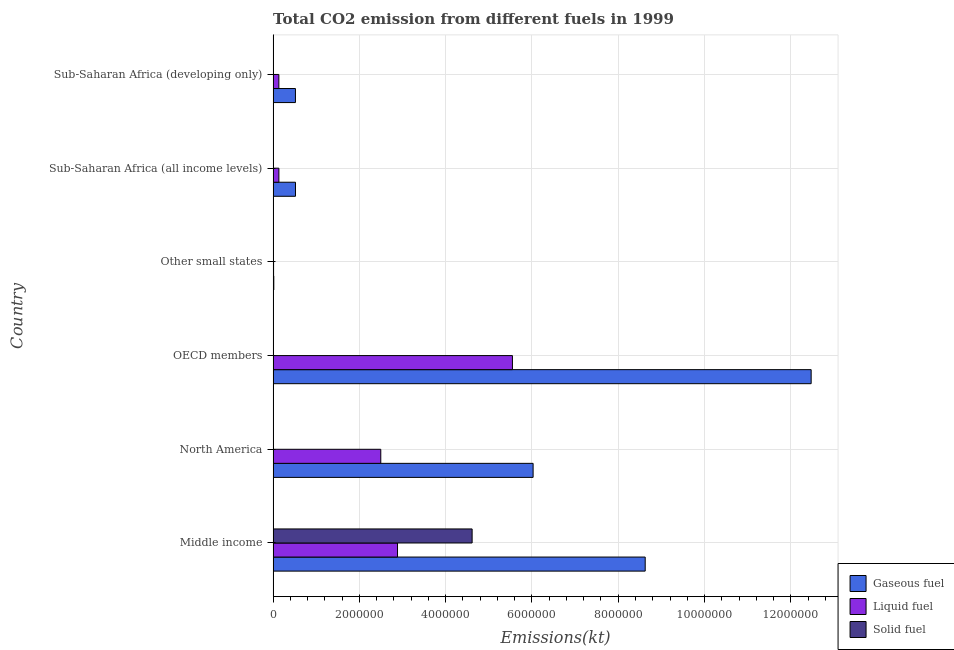Are the number of bars per tick equal to the number of legend labels?
Make the answer very short. Yes. Are the number of bars on each tick of the Y-axis equal?
Provide a short and direct response. Yes. What is the label of the 1st group of bars from the top?
Provide a short and direct response. Sub-Saharan Africa (developing only). In how many cases, is the number of bars for a given country not equal to the number of legend labels?
Offer a very short reply. 0. What is the amount of co2 emissions from liquid fuel in Middle income?
Your answer should be compact. 2.88e+06. Across all countries, what is the maximum amount of co2 emissions from gaseous fuel?
Offer a very short reply. 1.25e+07. Across all countries, what is the minimum amount of co2 emissions from gaseous fuel?
Offer a terse response. 1.56e+04. In which country was the amount of co2 emissions from gaseous fuel minimum?
Ensure brevity in your answer.  Other small states. What is the total amount of co2 emissions from gaseous fuel in the graph?
Provide a succinct answer. 2.82e+07. What is the difference between the amount of co2 emissions from gaseous fuel in OECD members and that in Other small states?
Provide a succinct answer. 1.25e+07. What is the difference between the amount of co2 emissions from solid fuel in Middle income and the amount of co2 emissions from liquid fuel in Sub-Saharan Africa (developing only)?
Your response must be concise. 4.48e+06. What is the average amount of co2 emissions from gaseous fuel per country?
Your answer should be very brief. 4.70e+06. What is the difference between the amount of co2 emissions from gaseous fuel and amount of co2 emissions from solid fuel in Sub-Saharan Africa (developing only)?
Your response must be concise. 5.17e+05. In how many countries, is the amount of co2 emissions from solid fuel greater than 12400000 kt?
Ensure brevity in your answer.  0. What is the ratio of the amount of co2 emissions from gaseous fuel in OECD members to that in Other small states?
Offer a terse response. 799.75. Is the amount of co2 emissions from gaseous fuel in Sub-Saharan Africa (all income levels) less than that in Sub-Saharan Africa (developing only)?
Your response must be concise. No. What is the difference between the highest and the second highest amount of co2 emissions from liquid fuel?
Your answer should be compact. 2.66e+06. What is the difference between the highest and the lowest amount of co2 emissions from solid fuel?
Ensure brevity in your answer.  4.61e+06. In how many countries, is the amount of co2 emissions from gaseous fuel greater than the average amount of co2 emissions from gaseous fuel taken over all countries?
Your response must be concise. 3. Is the sum of the amount of co2 emissions from gaseous fuel in OECD members and Sub-Saharan Africa (all income levels) greater than the maximum amount of co2 emissions from solid fuel across all countries?
Give a very brief answer. Yes. What does the 3rd bar from the top in Other small states represents?
Make the answer very short. Gaseous fuel. What does the 2nd bar from the bottom in Sub-Saharan Africa (all income levels) represents?
Offer a very short reply. Liquid fuel. Is it the case that in every country, the sum of the amount of co2 emissions from gaseous fuel and amount of co2 emissions from liquid fuel is greater than the amount of co2 emissions from solid fuel?
Provide a short and direct response. Yes. How many bars are there?
Make the answer very short. 18. Are all the bars in the graph horizontal?
Your answer should be compact. Yes. Are the values on the major ticks of X-axis written in scientific E-notation?
Your answer should be very brief. No. How many legend labels are there?
Provide a short and direct response. 3. What is the title of the graph?
Make the answer very short. Total CO2 emission from different fuels in 1999. What is the label or title of the X-axis?
Provide a short and direct response. Emissions(kt). What is the label or title of the Y-axis?
Your answer should be very brief. Country. What is the Emissions(kt) in Gaseous fuel in Middle income?
Make the answer very short. 8.62e+06. What is the Emissions(kt) in Liquid fuel in Middle income?
Provide a succinct answer. 2.88e+06. What is the Emissions(kt) in Solid fuel in Middle income?
Keep it short and to the point. 4.61e+06. What is the Emissions(kt) in Gaseous fuel in North America?
Make the answer very short. 6.03e+06. What is the Emissions(kt) of Liquid fuel in North America?
Your response must be concise. 2.50e+06. What is the Emissions(kt) of Solid fuel in North America?
Offer a very short reply. 3.67. What is the Emissions(kt) in Gaseous fuel in OECD members?
Keep it short and to the point. 1.25e+07. What is the Emissions(kt) of Liquid fuel in OECD members?
Offer a very short reply. 5.55e+06. What is the Emissions(kt) of Solid fuel in OECD members?
Provide a succinct answer. 110.01. What is the Emissions(kt) of Gaseous fuel in Other small states?
Offer a very short reply. 1.56e+04. What is the Emissions(kt) of Liquid fuel in Other small states?
Your answer should be very brief. 1.06e+04. What is the Emissions(kt) of Solid fuel in Other small states?
Provide a short and direct response. 2247.87. What is the Emissions(kt) of Gaseous fuel in Sub-Saharan Africa (all income levels)?
Your response must be concise. 5.18e+05. What is the Emissions(kt) in Liquid fuel in Sub-Saharan Africa (all income levels)?
Make the answer very short. 1.34e+05. What is the Emissions(kt) in Solid fuel in Sub-Saharan Africa (all income levels)?
Give a very brief answer. 2156.2. What is the Emissions(kt) of Gaseous fuel in Sub-Saharan Africa (developing only)?
Keep it short and to the point. 5.17e+05. What is the Emissions(kt) of Liquid fuel in Sub-Saharan Africa (developing only)?
Your answer should be compact. 1.33e+05. What is the Emissions(kt) in Solid fuel in Sub-Saharan Africa (developing only)?
Offer a terse response. 7.33. Across all countries, what is the maximum Emissions(kt) of Gaseous fuel?
Keep it short and to the point. 1.25e+07. Across all countries, what is the maximum Emissions(kt) in Liquid fuel?
Provide a short and direct response. 5.55e+06. Across all countries, what is the maximum Emissions(kt) of Solid fuel?
Your answer should be very brief. 4.61e+06. Across all countries, what is the minimum Emissions(kt) of Gaseous fuel?
Offer a terse response. 1.56e+04. Across all countries, what is the minimum Emissions(kt) in Liquid fuel?
Make the answer very short. 1.06e+04. Across all countries, what is the minimum Emissions(kt) of Solid fuel?
Make the answer very short. 3.67. What is the total Emissions(kt) in Gaseous fuel in the graph?
Ensure brevity in your answer.  2.82e+07. What is the total Emissions(kt) of Liquid fuel in the graph?
Give a very brief answer. 1.12e+07. What is the total Emissions(kt) of Solid fuel in the graph?
Provide a succinct answer. 4.62e+06. What is the difference between the Emissions(kt) in Gaseous fuel in Middle income and that in North America?
Ensure brevity in your answer.  2.60e+06. What is the difference between the Emissions(kt) in Liquid fuel in Middle income and that in North America?
Your answer should be very brief. 3.88e+05. What is the difference between the Emissions(kt) in Solid fuel in Middle income and that in North America?
Keep it short and to the point. 4.61e+06. What is the difference between the Emissions(kt) of Gaseous fuel in Middle income and that in OECD members?
Ensure brevity in your answer.  -3.85e+06. What is the difference between the Emissions(kt) of Liquid fuel in Middle income and that in OECD members?
Provide a short and direct response. -2.66e+06. What is the difference between the Emissions(kt) in Solid fuel in Middle income and that in OECD members?
Your answer should be compact. 4.61e+06. What is the difference between the Emissions(kt) in Gaseous fuel in Middle income and that in Other small states?
Provide a succinct answer. 8.61e+06. What is the difference between the Emissions(kt) in Liquid fuel in Middle income and that in Other small states?
Make the answer very short. 2.87e+06. What is the difference between the Emissions(kt) of Solid fuel in Middle income and that in Other small states?
Offer a terse response. 4.61e+06. What is the difference between the Emissions(kt) of Gaseous fuel in Middle income and that in Sub-Saharan Africa (all income levels)?
Offer a very short reply. 8.11e+06. What is the difference between the Emissions(kt) in Liquid fuel in Middle income and that in Sub-Saharan Africa (all income levels)?
Make the answer very short. 2.75e+06. What is the difference between the Emissions(kt) in Solid fuel in Middle income and that in Sub-Saharan Africa (all income levels)?
Offer a terse response. 4.61e+06. What is the difference between the Emissions(kt) in Gaseous fuel in Middle income and that in Sub-Saharan Africa (developing only)?
Keep it short and to the point. 8.11e+06. What is the difference between the Emissions(kt) in Liquid fuel in Middle income and that in Sub-Saharan Africa (developing only)?
Your answer should be very brief. 2.75e+06. What is the difference between the Emissions(kt) of Solid fuel in Middle income and that in Sub-Saharan Africa (developing only)?
Keep it short and to the point. 4.61e+06. What is the difference between the Emissions(kt) of Gaseous fuel in North America and that in OECD members?
Your answer should be very brief. -6.45e+06. What is the difference between the Emissions(kt) of Liquid fuel in North America and that in OECD members?
Keep it short and to the point. -3.05e+06. What is the difference between the Emissions(kt) of Solid fuel in North America and that in OECD members?
Your answer should be compact. -106.34. What is the difference between the Emissions(kt) in Gaseous fuel in North America and that in Other small states?
Ensure brevity in your answer.  6.01e+06. What is the difference between the Emissions(kt) of Liquid fuel in North America and that in Other small states?
Offer a terse response. 2.49e+06. What is the difference between the Emissions(kt) of Solid fuel in North America and that in Other small states?
Give a very brief answer. -2244.2. What is the difference between the Emissions(kt) in Gaseous fuel in North America and that in Sub-Saharan Africa (all income levels)?
Provide a short and direct response. 5.51e+06. What is the difference between the Emissions(kt) of Liquid fuel in North America and that in Sub-Saharan Africa (all income levels)?
Keep it short and to the point. 2.36e+06. What is the difference between the Emissions(kt) in Solid fuel in North America and that in Sub-Saharan Africa (all income levels)?
Ensure brevity in your answer.  -2152.53. What is the difference between the Emissions(kt) in Gaseous fuel in North America and that in Sub-Saharan Africa (developing only)?
Keep it short and to the point. 5.51e+06. What is the difference between the Emissions(kt) of Liquid fuel in North America and that in Sub-Saharan Africa (developing only)?
Give a very brief answer. 2.36e+06. What is the difference between the Emissions(kt) of Solid fuel in North America and that in Sub-Saharan Africa (developing only)?
Offer a very short reply. -3.67. What is the difference between the Emissions(kt) of Gaseous fuel in OECD members and that in Other small states?
Your answer should be very brief. 1.25e+07. What is the difference between the Emissions(kt) of Liquid fuel in OECD members and that in Other small states?
Offer a terse response. 5.54e+06. What is the difference between the Emissions(kt) of Solid fuel in OECD members and that in Other small states?
Provide a succinct answer. -2137.86. What is the difference between the Emissions(kt) of Gaseous fuel in OECD members and that in Sub-Saharan Africa (all income levels)?
Your answer should be very brief. 1.20e+07. What is the difference between the Emissions(kt) of Liquid fuel in OECD members and that in Sub-Saharan Africa (all income levels)?
Make the answer very short. 5.41e+06. What is the difference between the Emissions(kt) in Solid fuel in OECD members and that in Sub-Saharan Africa (all income levels)?
Offer a terse response. -2046.19. What is the difference between the Emissions(kt) of Gaseous fuel in OECD members and that in Sub-Saharan Africa (developing only)?
Provide a succinct answer. 1.20e+07. What is the difference between the Emissions(kt) in Liquid fuel in OECD members and that in Sub-Saharan Africa (developing only)?
Your response must be concise. 5.41e+06. What is the difference between the Emissions(kt) in Solid fuel in OECD members and that in Sub-Saharan Africa (developing only)?
Your answer should be compact. 102.68. What is the difference between the Emissions(kt) in Gaseous fuel in Other small states and that in Sub-Saharan Africa (all income levels)?
Provide a succinct answer. -5.03e+05. What is the difference between the Emissions(kt) of Liquid fuel in Other small states and that in Sub-Saharan Africa (all income levels)?
Keep it short and to the point. -1.23e+05. What is the difference between the Emissions(kt) in Solid fuel in Other small states and that in Sub-Saharan Africa (all income levels)?
Provide a short and direct response. 91.67. What is the difference between the Emissions(kt) in Gaseous fuel in Other small states and that in Sub-Saharan Africa (developing only)?
Give a very brief answer. -5.02e+05. What is the difference between the Emissions(kt) in Liquid fuel in Other small states and that in Sub-Saharan Africa (developing only)?
Offer a very short reply. -1.22e+05. What is the difference between the Emissions(kt) in Solid fuel in Other small states and that in Sub-Saharan Africa (developing only)?
Offer a very short reply. 2240.54. What is the difference between the Emissions(kt) of Gaseous fuel in Sub-Saharan Africa (all income levels) and that in Sub-Saharan Africa (developing only)?
Your response must be concise. 971.17. What is the difference between the Emissions(kt) in Liquid fuel in Sub-Saharan Africa (all income levels) and that in Sub-Saharan Africa (developing only)?
Give a very brief answer. 901.99. What is the difference between the Emissions(kt) of Solid fuel in Sub-Saharan Africa (all income levels) and that in Sub-Saharan Africa (developing only)?
Give a very brief answer. 2148.86. What is the difference between the Emissions(kt) in Gaseous fuel in Middle income and the Emissions(kt) in Liquid fuel in North America?
Ensure brevity in your answer.  6.13e+06. What is the difference between the Emissions(kt) of Gaseous fuel in Middle income and the Emissions(kt) of Solid fuel in North America?
Offer a very short reply. 8.62e+06. What is the difference between the Emissions(kt) in Liquid fuel in Middle income and the Emissions(kt) in Solid fuel in North America?
Offer a terse response. 2.88e+06. What is the difference between the Emissions(kt) of Gaseous fuel in Middle income and the Emissions(kt) of Liquid fuel in OECD members?
Offer a terse response. 3.08e+06. What is the difference between the Emissions(kt) in Gaseous fuel in Middle income and the Emissions(kt) in Solid fuel in OECD members?
Your response must be concise. 8.62e+06. What is the difference between the Emissions(kt) of Liquid fuel in Middle income and the Emissions(kt) of Solid fuel in OECD members?
Provide a succinct answer. 2.88e+06. What is the difference between the Emissions(kt) in Gaseous fuel in Middle income and the Emissions(kt) in Liquid fuel in Other small states?
Your answer should be compact. 8.61e+06. What is the difference between the Emissions(kt) of Gaseous fuel in Middle income and the Emissions(kt) of Solid fuel in Other small states?
Provide a short and direct response. 8.62e+06. What is the difference between the Emissions(kt) in Liquid fuel in Middle income and the Emissions(kt) in Solid fuel in Other small states?
Your response must be concise. 2.88e+06. What is the difference between the Emissions(kt) of Gaseous fuel in Middle income and the Emissions(kt) of Liquid fuel in Sub-Saharan Africa (all income levels)?
Ensure brevity in your answer.  8.49e+06. What is the difference between the Emissions(kt) in Gaseous fuel in Middle income and the Emissions(kt) in Solid fuel in Sub-Saharan Africa (all income levels)?
Your answer should be compact. 8.62e+06. What is the difference between the Emissions(kt) of Liquid fuel in Middle income and the Emissions(kt) of Solid fuel in Sub-Saharan Africa (all income levels)?
Ensure brevity in your answer.  2.88e+06. What is the difference between the Emissions(kt) in Gaseous fuel in Middle income and the Emissions(kt) in Liquid fuel in Sub-Saharan Africa (developing only)?
Offer a very short reply. 8.49e+06. What is the difference between the Emissions(kt) in Gaseous fuel in Middle income and the Emissions(kt) in Solid fuel in Sub-Saharan Africa (developing only)?
Provide a succinct answer. 8.62e+06. What is the difference between the Emissions(kt) in Liquid fuel in Middle income and the Emissions(kt) in Solid fuel in Sub-Saharan Africa (developing only)?
Keep it short and to the point. 2.88e+06. What is the difference between the Emissions(kt) of Gaseous fuel in North America and the Emissions(kt) of Liquid fuel in OECD members?
Ensure brevity in your answer.  4.79e+05. What is the difference between the Emissions(kt) of Gaseous fuel in North America and the Emissions(kt) of Solid fuel in OECD members?
Provide a short and direct response. 6.03e+06. What is the difference between the Emissions(kt) in Liquid fuel in North America and the Emissions(kt) in Solid fuel in OECD members?
Ensure brevity in your answer.  2.50e+06. What is the difference between the Emissions(kt) of Gaseous fuel in North America and the Emissions(kt) of Liquid fuel in Other small states?
Your answer should be compact. 6.02e+06. What is the difference between the Emissions(kt) in Gaseous fuel in North America and the Emissions(kt) in Solid fuel in Other small states?
Make the answer very short. 6.02e+06. What is the difference between the Emissions(kt) in Liquid fuel in North America and the Emissions(kt) in Solid fuel in Other small states?
Offer a terse response. 2.49e+06. What is the difference between the Emissions(kt) in Gaseous fuel in North America and the Emissions(kt) in Liquid fuel in Sub-Saharan Africa (all income levels)?
Provide a succinct answer. 5.89e+06. What is the difference between the Emissions(kt) in Gaseous fuel in North America and the Emissions(kt) in Solid fuel in Sub-Saharan Africa (all income levels)?
Offer a very short reply. 6.02e+06. What is the difference between the Emissions(kt) of Liquid fuel in North America and the Emissions(kt) of Solid fuel in Sub-Saharan Africa (all income levels)?
Offer a terse response. 2.49e+06. What is the difference between the Emissions(kt) in Gaseous fuel in North America and the Emissions(kt) in Liquid fuel in Sub-Saharan Africa (developing only)?
Make the answer very short. 5.89e+06. What is the difference between the Emissions(kt) in Gaseous fuel in North America and the Emissions(kt) in Solid fuel in Sub-Saharan Africa (developing only)?
Offer a very short reply. 6.03e+06. What is the difference between the Emissions(kt) in Liquid fuel in North America and the Emissions(kt) in Solid fuel in Sub-Saharan Africa (developing only)?
Provide a short and direct response. 2.50e+06. What is the difference between the Emissions(kt) in Gaseous fuel in OECD members and the Emissions(kt) in Liquid fuel in Other small states?
Give a very brief answer. 1.25e+07. What is the difference between the Emissions(kt) in Gaseous fuel in OECD members and the Emissions(kt) in Solid fuel in Other small states?
Offer a very short reply. 1.25e+07. What is the difference between the Emissions(kt) of Liquid fuel in OECD members and the Emissions(kt) of Solid fuel in Other small states?
Your response must be concise. 5.55e+06. What is the difference between the Emissions(kt) of Gaseous fuel in OECD members and the Emissions(kt) of Liquid fuel in Sub-Saharan Africa (all income levels)?
Give a very brief answer. 1.23e+07. What is the difference between the Emissions(kt) in Gaseous fuel in OECD members and the Emissions(kt) in Solid fuel in Sub-Saharan Africa (all income levels)?
Provide a short and direct response. 1.25e+07. What is the difference between the Emissions(kt) of Liquid fuel in OECD members and the Emissions(kt) of Solid fuel in Sub-Saharan Africa (all income levels)?
Your answer should be very brief. 5.55e+06. What is the difference between the Emissions(kt) of Gaseous fuel in OECD members and the Emissions(kt) of Liquid fuel in Sub-Saharan Africa (developing only)?
Give a very brief answer. 1.23e+07. What is the difference between the Emissions(kt) of Gaseous fuel in OECD members and the Emissions(kt) of Solid fuel in Sub-Saharan Africa (developing only)?
Offer a very short reply. 1.25e+07. What is the difference between the Emissions(kt) in Liquid fuel in OECD members and the Emissions(kt) in Solid fuel in Sub-Saharan Africa (developing only)?
Keep it short and to the point. 5.55e+06. What is the difference between the Emissions(kt) in Gaseous fuel in Other small states and the Emissions(kt) in Liquid fuel in Sub-Saharan Africa (all income levels)?
Provide a short and direct response. -1.18e+05. What is the difference between the Emissions(kt) in Gaseous fuel in Other small states and the Emissions(kt) in Solid fuel in Sub-Saharan Africa (all income levels)?
Provide a short and direct response. 1.34e+04. What is the difference between the Emissions(kt) in Liquid fuel in Other small states and the Emissions(kt) in Solid fuel in Sub-Saharan Africa (all income levels)?
Your answer should be very brief. 8456.78. What is the difference between the Emissions(kt) of Gaseous fuel in Other small states and the Emissions(kt) of Liquid fuel in Sub-Saharan Africa (developing only)?
Your response must be concise. -1.17e+05. What is the difference between the Emissions(kt) of Gaseous fuel in Other small states and the Emissions(kt) of Solid fuel in Sub-Saharan Africa (developing only)?
Your response must be concise. 1.56e+04. What is the difference between the Emissions(kt) of Liquid fuel in Other small states and the Emissions(kt) of Solid fuel in Sub-Saharan Africa (developing only)?
Give a very brief answer. 1.06e+04. What is the difference between the Emissions(kt) of Gaseous fuel in Sub-Saharan Africa (all income levels) and the Emissions(kt) of Liquid fuel in Sub-Saharan Africa (developing only)?
Offer a terse response. 3.85e+05. What is the difference between the Emissions(kt) in Gaseous fuel in Sub-Saharan Africa (all income levels) and the Emissions(kt) in Solid fuel in Sub-Saharan Africa (developing only)?
Your answer should be compact. 5.18e+05. What is the difference between the Emissions(kt) of Liquid fuel in Sub-Saharan Africa (all income levels) and the Emissions(kt) of Solid fuel in Sub-Saharan Africa (developing only)?
Make the answer very short. 1.34e+05. What is the average Emissions(kt) in Gaseous fuel per country?
Ensure brevity in your answer.  4.70e+06. What is the average Emissions(kt) in Liquid fuel per country?
Offer a terse response. 1.87e+06. What is the average Emissions(kt) of Solid fuel per country?
Make the answer very short. 7.70e+05. What is the difference between the Emissions(kt) of Gaseous fuel and Emissions(kt) of Liquid fuel in Middle income?
Make the answer very short. 5.74e+06. What is the difference between the Emissions(kt) in Gaseous fuel and Emissions(kt) in Solid fuel in Middle income?
Your response must be concise. 4.01e+06. What is the difference between the Emissions(kt) in Liquid fuel and Emissions(kt) in Solid fuel in Middle income?
Offer a terse response. -1.73e+06. What is the difference between the Emissions(kt) of Gaseous fuel and Emissions(kt) of Liquid fuel in North America?
Keep it short and to the point. 3.53e+06. What is the difference between the Emissions(kt) of Gaseous fuel and Emissions(kt) of Solid fuel in North America?
Make the answer very short. 6.03e+06. What is the difference between the Emissions(kt) in Liquid fuel and Emissions(kt) in Solid fuel in North America?
Your answer should be very brief. 2.50e+06. What is the difference between the Emissions(kt) of Gaseous fuel and Emissions(kt) of Liquid fuel in OECD members?
Give a very brief answer. 6.92e+06. What is the difference between the Emissions(kt) in Gaseous fuel and Emissions(kt) in Solid fuel in OECD members?
Offer a terse response. 1.25e+07. What is the difference between the Emissions(kt) in Liquid fuel and Emissions(kt) in Solid fuel in OECD members?
Keep it short and to the point. 5.55e+06. What is the difference between the Emissions(kt) in Gaseous fuel and Emissions(kt) in Liquid fuel in Other small states?
Keep it short and to the point. 4981.35. What is the difference between the Emissions(kt) of Gaseous fuel and Emissions(kt) of Solid fuel in Other small states?
Ensure brevity in your answer.  1.33e+04. What is the difference between the Emissions(kt) of Liquid fuel and Emissions(kt) of Solid fuel in Other small states?
Provide a succinct answer. 8365.1. What is the difference between the Emissions(kt) of Gaseous fuel and Emissions(kt) of Liquid fuel in Sub-Saharan Africa (all income levels)?
Provide a succinct answer. 3.84e+05. What is the difference between the Emissions(kt) of Gaseous fuel and Emissions(kt) of Solid fuel in Sub-Saharan Africa (all income levels)?
Provide a succinct answer. 5.16e+05. What is the difference between the Emissions(kt) of Liquid fuel and Emissions(kt) of Solid fuel in Sub-Saharan Africa (all income levels)?
Offer a terse response. 1.32e+05. What is the difference between the Emissions(kt) in Gaseous fuel and Emissions(kt) in Liquid fuel in Sub-Saharan Africa (developing only)?
Provide a succinct answer. 3.84e+05. What is the difference between the Emissions(kt) of Gaseous fuel and Emissions(kt) of Solid fuel in Sub-Saharan Africa (developing only)?
Your response must be concise. 5.17e+05. What is the difference between the Emissions(kt) in Liquid fuel and Emissions(kt) in Solid fuel in Sub-Saharan Africa (developing only)?
Ensure brevity in your answer.  1.33e+05. What is the ratio of the Emissions(kt) in Gaseous fuel in Middle income to that in North America?
Ensure brevity in your answer.  1.43. What is the ratio of the Emissions(kt) in Liquid fuel in Middle income to that in North America?
Offer a very short reply. 1.16. What is the ratio of the Emissions(kt) of Solid fuel in Middle income to that in North America?
Your response must be concise. 1.26e+06. What is the ratio of the Emissions(kt) of Gaseous fuel in Middle income to that in OECD members?
Make the answer very short. 0.69. What is the ratio of the Emissions(kt) of Liquid fuel in Middle income to that in OECD members?
Your answer should be very brief. 0.52. What is the ratio of the Emissions(kt) in Solid fuel in Middle income to that in OECD members?
Provide a short and direct response. 4.19e+04. What is the ratio of the Emissions(kt) of Gaseous fuel in Middle income to that in Other small states?
Keep it short and to the point. 553.07. What is the ratio of the Emissions(kt) in Liquid fuel in Middle income to that in Other small states?
Provide a short and direct response. 271.69. What is the ratio of the Emissions(kt) of Solid fuel in Middle income to that in Other small states?
Keep it short and to the point. 2052.2. What is the ratio of the Emissions(kt) in Gaseous fuel in Middle income to that in Sub-Saharan Africa (all income levels)?
Offer a terse response. 16.64. What is the ratio of the Emissions(kt) of Liquid fuel in Middle income to that in Sub-Saharan Africa (all income levels)?
Keep it short and to the point. 21.54. What is the ratio of the Emissions(kt) of Solid fuel in Middle income to that in Sub-Saharan Africa (all income levels)?
Your answer should be very brief. 2139.46. What is the ratio of the Emissions(kt) in Gaseous fuel in Middle income to that in Sub-Saharan Africa (developing only)?
Ensure brevity in your answer.  16.67. What is the ratio of the Emissions(kt) of Liquid fuel in Middle income to that in Sub-Saharan Africa (developing only)?
Your answer should be very brief. 21.68. What is the ratio of the Emissions(kt) in Solid fuel in Middle income to that in Sub-Saharan Africa (developing only)?
Provide a short and direct response. 6.29e+05. What is the ratio of the Emissions(kt) in Gaseous fuel in North America to that in OECD members?
Your answer should be compact. 0.48. What is the ratio of the Emissions(kt) in Liquid fuel in North America to that in OECD members?
Offer a terse response. 0.45. What is the ratio of the Emissions(kt) in Gaseous fuel in North America to that in Other small states?
Offer a terse response. 386.45. What is the ratio of the Emissions(kt) of Liquid fuel in North America to that in Other small states?
Offer a terse response. 235.15. What is the ratio of the Emissions(kt) of Solid fuel in North America to that in Other small states?
Keep it short and to the point. 0. What is the ratio of the Emissions(kt) in Gaseous fuel in North America to that in Sub-Saharan Africa (all income levels)?
Keep it short and to the point. 11.63. What is the ratio of the Emissions(kt) of Liquid fuel in North America to that in Sub-Saharan Africa (all income levels)?
Make the answer very short. 18.64. What is the ratio of the Emissions(kt) in Solid fuel in North America to that in Sub-Saharan Africa (all income levels)?
Your answer should be compact. 0. What is the ratio of the Emissions(kt) of Gaseous fuel in North America to that in Sub-Saharan Africa (developing only)?
Offer a very short reply. 11.65. What is the ratio of the Emissions(kt) of Liquid fuel in North America to that in Sub-Saharan Africa (developing only)?
Provide a succinct answer. 18.77. What is the ratio of the Emissions(kt) of Solid fuel in North America to that in Sub-Saharan Africa (developing only)?
Provide a short and direct response. 0.5. What is the ratio of the Emissions(kt) in Gaseous fuel in OECD members to that in Other small states?
Ensure brevity in your answer.  799.75. What is the ratio of the Emissions(kt) in Liquid fuel in OECD members to that in Other small states?
Your answer should be very brief. 522.71. What is the ratio of the Emissions(kt) in Solid fuel in OECD members to that in Other small states?
Give a very brief answer. 0.05. What is the ratio of the Emissions(kt) in Gaseous fuel in OECD members to that in Sub-Saharan Africa (all income levels)?
Keep it short and to the point. 24.07. What is the ratio of the Emissions(kt) in Liquid fuel in OECD members to that in Sub-Saharan Africa (all income levels)?
Ensure brevity in your answer.  41.44. What is the ratio of the Emissions(kt) of Solid fuel in OECD members to that in Sub-Saharan Africa (all income levels)?
Provide a succinct answer. 0.05. What is the ratio of the Emissions(kt) in Gaseous fuel in OECD members to that in Sub-Saharan Africa (developing only)?
Offer a very short reply. 24.11. What is the ratio of the Emissions(kt) in Liquid fuel in OECD members to that in Sub-Saharan Africa (developing only)?
Ensure brevity in your answer.  41.72. What is the ratio of the Emissions(kt) of Gaseous fuel in Other small states to that in Sub-Saharan Africa (all income levels)?
Offer a very short reply. 0.03. What is the ratio of the Emissions(kt) of Liquid fuel in Other small states to that in Sub-Saharan Africa (all income levels)?
Ensure brevity in your answer.  0.08. What is the ratio of the Emissions(kt) of Solid fuel in Other small states to that in Sub-Saharan Africa (all income levels)?
Make the answer very short. 1.04. What is the ratio of the Emissions(kt) in Gaseous fuel in Other small states to that in Sub-Saharan Africa (developing only)?
Provide a short and direct response. 0.03. What is the ratio of the Emissions(kt) in Liquid fuel in Other small states to that in Sub-Saharan Africa (developing only)?
Your answer should be compact. 0.08. What is the ratio of the Emissions(kt) in Solid fuel in Other small states to that in Sub-Saharan Africa (developing only)?
Keep it short and to the point. 306.5. What is the ratio of the Emissions(kt) of Liquid fuel in Sub-Saharan Africa (all income levels) to that in Sub-Saharan Africa (developing only)?
Your response must be concise. 1.01. What is the ratio of the Emissions(kt) in Solid fuel in Sub-Saharan Africa (all income levels) to that in Sub-Saharan Africa (developing only)?
Your answer should be very brief. 294. What is the difference between the highest and the second highest Emissions(kt) in Gaseous fuel?
Give a very brief answer. 3.85e+06. What is the difference between the highest and the second highest Emissions(kt) of Liquid fuel?
Make the answer very short. 2.66e+06. What is the difference between the highest and the second highest Emissions(kt) of Solid fuel?
Ensure brevity in your answer.  4.61e+06. What is the difference between the highest and the lowest Emissions(kt) of Gaseous fuel?
Provide a succinct answer. 1.25e+07. What is the difference between the highest and the lowest Emissions(kt) of Liquid fuel?
Provide a short and direct response. 5.54e+06. What is the difference between the highest and the lowest Emissions(kt) in Solid fuel?
Make the answer very short. 4.61e+06. 